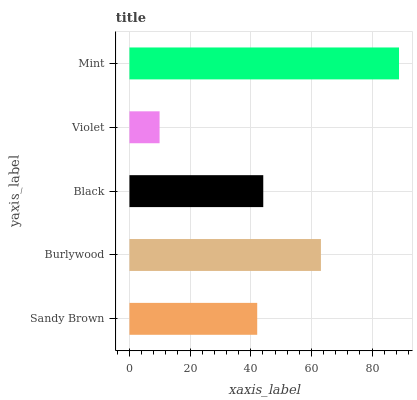Is Violet the minimum?
Answer yes or no. Yes. Is Mint the maximum?
Answer yes or no. Yes. Is Burlywood the minimum?
Answer yes or no. No. Is Burlywood the maximum?
Answer yes or no. No. Is Burlywood greater than Sandy Brown?
Answer yes or no. Yes. Is Sandy Brown less than Burlywood?
Answer yes or no. Yes. Is Sandy Brown greater than Burlywood?
Answer yes or no. No. Is Burlywood less than Sandy Brown?
Answer yes or no. No. Is Black the high median?
Answer yes or no. Yes. Is Black the low median?
Answer yes or no. Yes. Is Mint the high median?
Answer yes or no. No. Is Burlywood the low median?
Answer yes or no. No. 